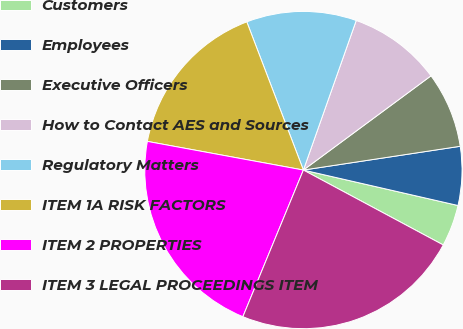<chart> <loc_0><loc_0><loc_500><loc_500><pie_chart><fcel>Customers<fcel>Employees<fcel>Executive Officers<fcel>How to Contact AES and Sources<fcel>Regulatory Matters<fcel>ITEM 1A RISK FACTORS<fcel>ITEM 2 PROPERTIES<fcel>ITEM 3 LEGAL PROCEEDINGS ITEM<nl><fcel>4.24%<fcel>5.98%<fcel>7.73%<fcel>9.47%<fcel>11.21%<fcel>16.3%<fcel>21.66%<fcel>23.4%<nl></chart> 